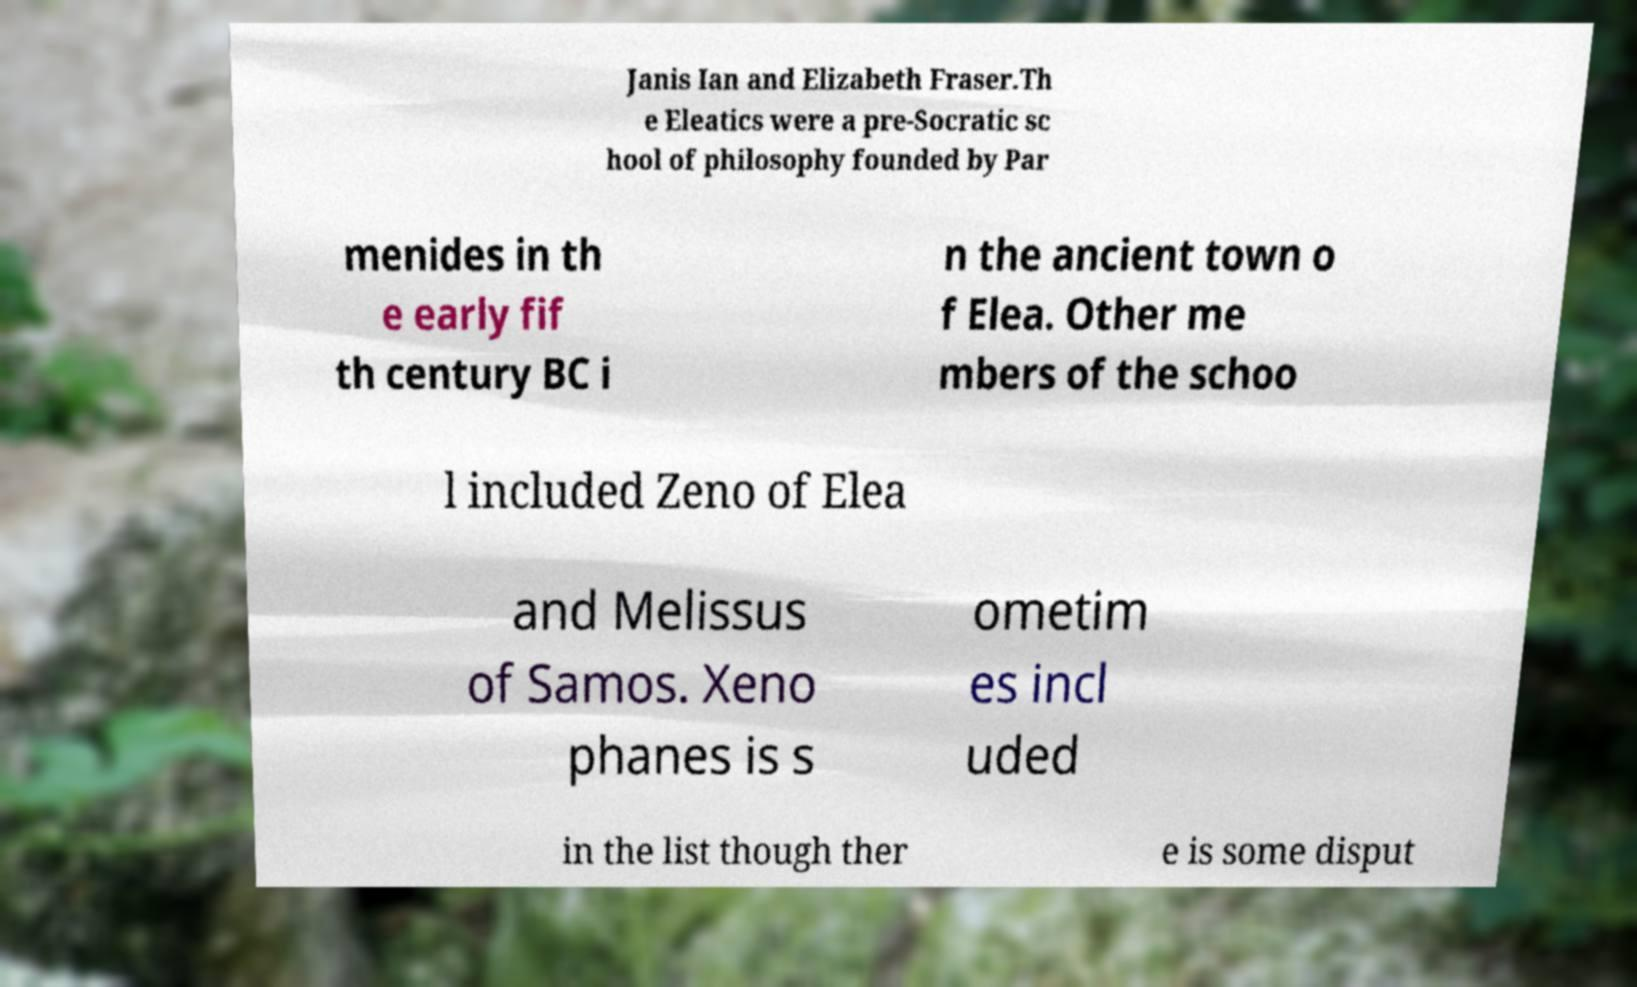There's text embedded in this image that I need extracted. Can you transcribe it verbatim? Janis Ian and Elizabeth Fraser.Th e Eleatics were a pre-Socratic sc hool of philosophy founded by Par menides in th e early fif th century BC i n the ancient town o f Elea. Other me mbers of the schoo l included Zeno of Elea and Melissus of Samos. Xeno phanes is s ometim es incl uded in the list though ther e is some disput 